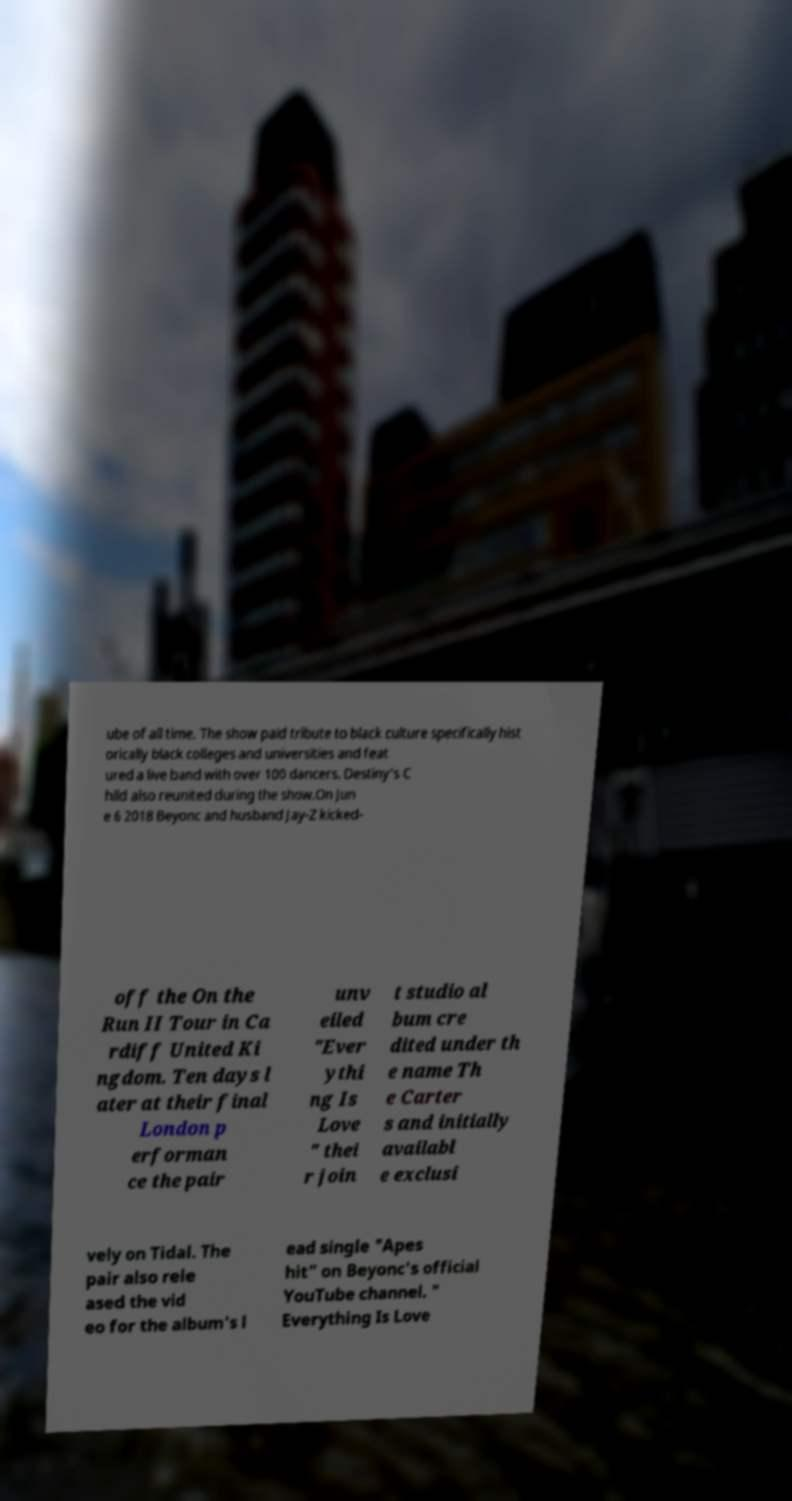Please identify and transcribe the text found in this image. ube of all time. The show paid tribute to black culture specifically hist orically black colleges and universities and feat ured a live band with over 100 dancers. Destiny's C hild also reunited during the show.On Jun e 6 2018 Beyonc and husband Jay-Z kicked- off the On the Run II Tour in Ca rdiff United Ki ngdom. Ten days l ater at their final London p erforman ce the pair unv eiled "Ever ythi ng Is Love " thei r join t studio al bum cre dited under th e name Th e Carter s and initially availabl e exclusi vely on Tidal. The pair also rele ased the vid eo for the album's l ead single "Apes hit" on Beyonc's official YouTube channel. " Everything Is Love 